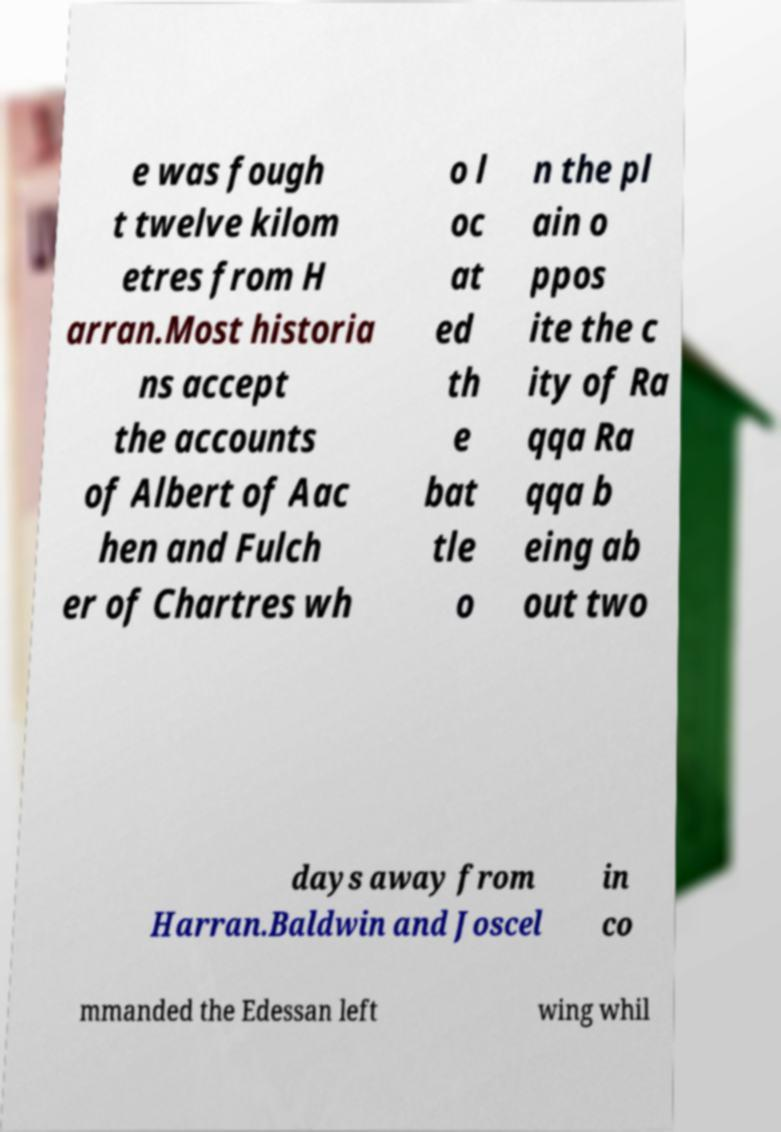What messages or text are displayed in this image? I need them in a readable, typed format. e was fough t twelve kilom etres from H arran.Most historia ns accept the accounts of Albert of Aac hen and Fulch er of Chartres wh o l oc at ed th e bat tle o n the pl ain o ppos ite the c ity of Ra qqa Ra qqa b eing ab out two days away from Harran.Baldwin and Joscel in co mmanded the Edessan left wing whil 